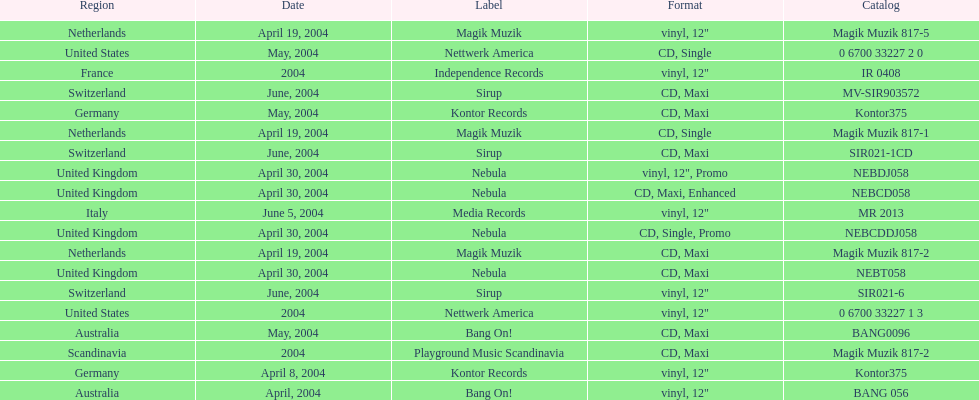What region is above australia? Germany. 